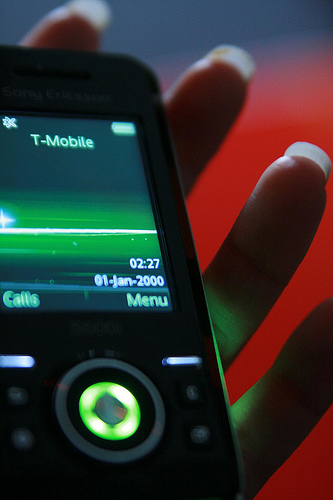<image>
Can you confirm if the phone is on the finger? Yes. Looking at the image, I can see the phone is positioned on top of the finger, with the finger providing support. 